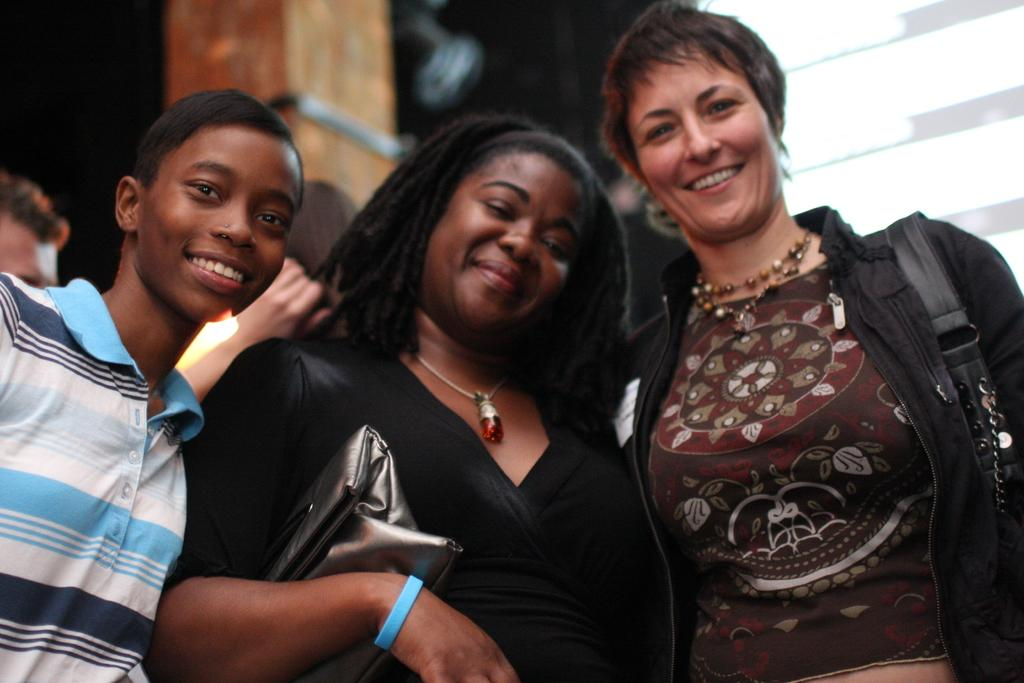How many people are in the image? There are people in the image, but the exact number is not specified. What is the facial expression of the people in the image? The people in the image are smiling. What is one person holding in the image? One person is holding a bag. What can be seen in the background of the image? There is a pillar in the background of the image. How would you describe the lighting in the image? The background of the image is dark and not clear. What scientific attraction is visible in the image? There is no scientific attraction present in the image. Is there a flame visible in the image? There is no flame visible in the image. 